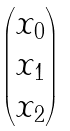<formula> <loc_0><loc_0><loc_500><loc_500>\begin{pmatrix} x _ { 0 } \\ x _ { 1 } \\ x _ { 2 } \end{pmatrix}</formula> 